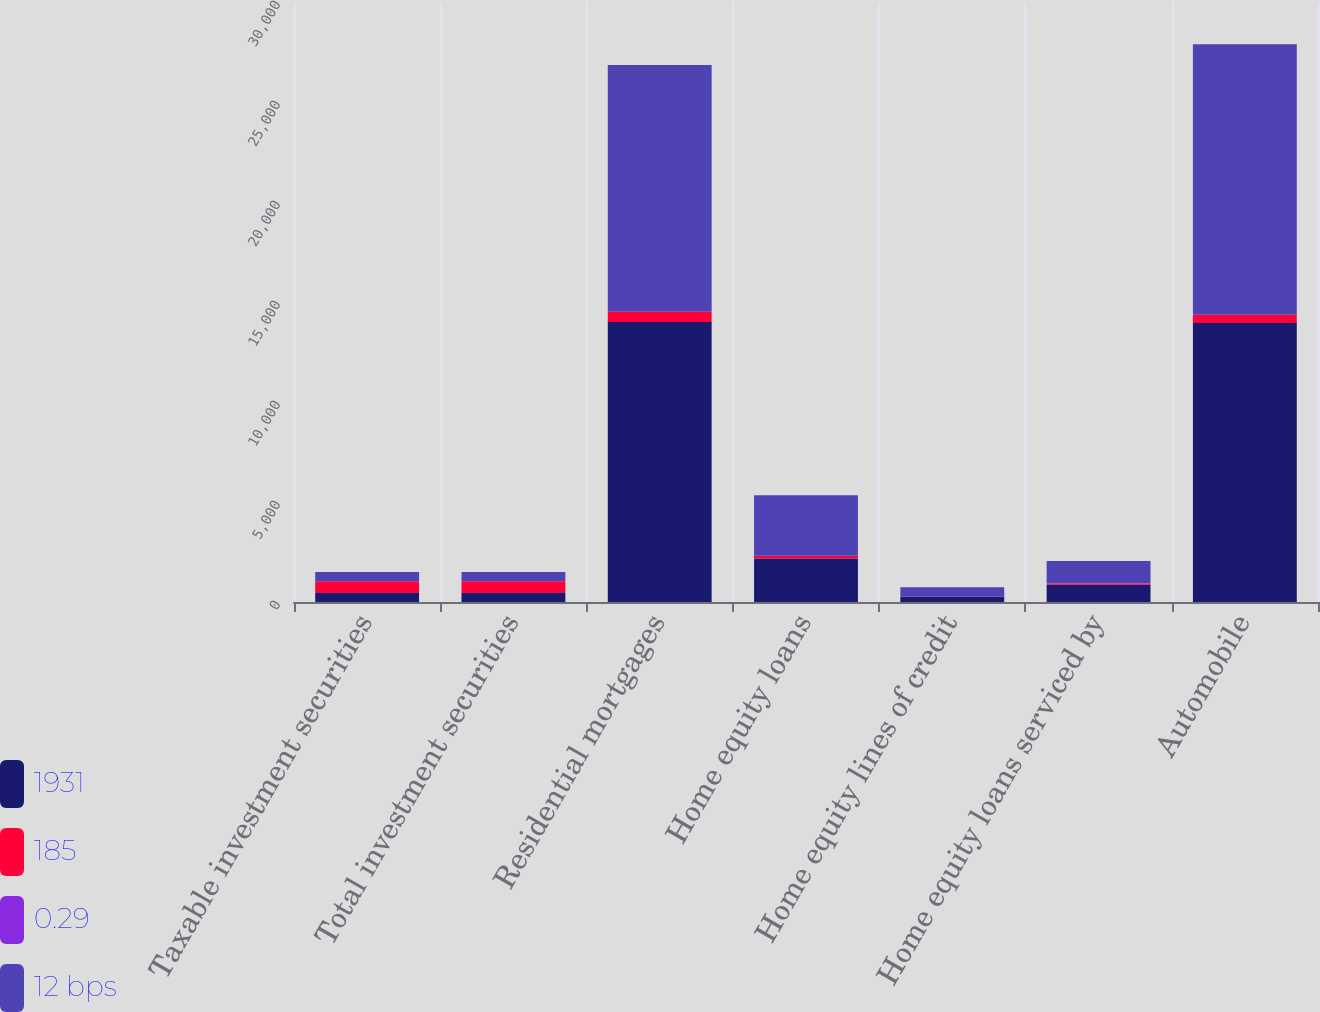Convert chart to OTSL. <chart><loc_0><loc_0><loc_500><loc_500><stacked_bar_chart><ecel><fcel>Taxable investment securities<fcel>Total investment securities<fcel>Residential mortgages<fcel>Home equity loans<fcel>Home equity lines of credit<fcel>Home equity loans serviced by<fcel>Automobile<nl><fcel>1931<fcel>455<fcel>455<fcel>14005<fcel>2180<fcel>281<fcel>867<fcel>13953<nl><fcel>185<fcel>584<fcel>584<fcel>504<fcel>123<fcel>7<fcel>62<fcel>411<nl><fcel>0.29<fcel>2.37<fcel>2.37<fcel>3.6<fcel>5.64<fcel>2.41<fcel>7.11<fcel>2.94<nl><fcel>12 bps<fcel>455<fcel>455<fcel>12338<fcel>3025<fcel>453<fcel>1117<fcel>13516<nl></chart> 